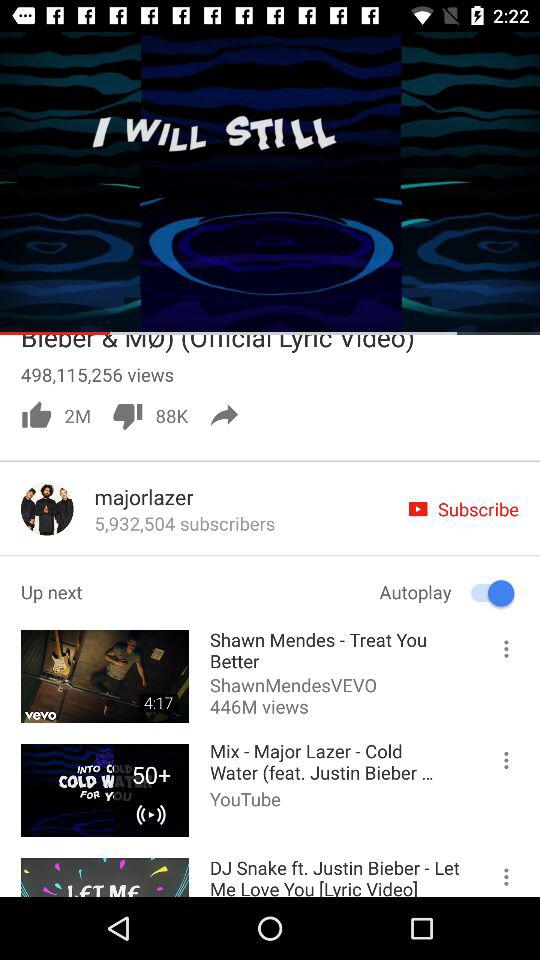What is the duration of Coldplay- Adventure of a lifetime(official video)?
When the provided information is insufficient, respond with <no answer>. <no answer> 